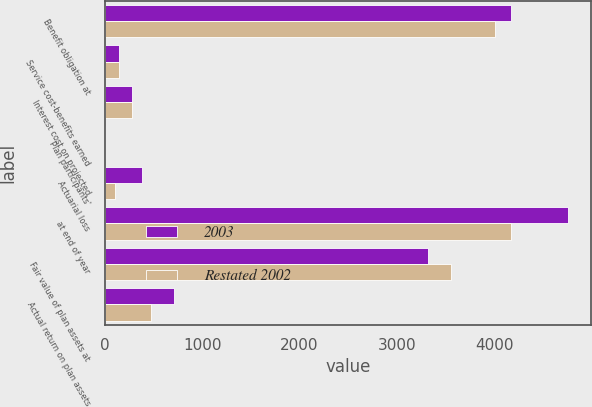Convert chart to OTSL. <chart><loc_0><loc_0><loc_500><loc_500><stacked_bar_chart><ecel><fcel>Benefit obligation at<fcel>Service cost-benefits earned<fcel>Interest cost on projected<fcel>Plan participants'<fcel>Actuarial loss<fcel>at end of year<fcel>Fair value of plan assets at<fcel>Actual return on plan assets<nl><fcel>2003<fcel>4172<fcel>144<fcel>275<fcel>3<fcel>382<fcel>4755<fcel>3318<fcel>707<nl><fcel>Restated 2002<fcel>4012<fcel>143<fcel>275<fcel>1<fcel>107<fcel>4172<fcel>3557<fcel>473<nl></chart> 